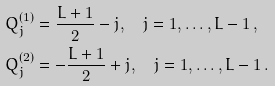<formula> <loc_0><loc_0><loc_500><loc_500>Q _ { j } ^ { ( 1 ) } & = \frac { L + 1 } { 2 } - j , \quad j = 1 , \dots , L - 1 \, , \\ Q _ { j } ^ { ( 2 ) } & = - \frac { L + 1 } { 2 } + j , \quad j = 1 , \dots , L - 1 \, .</formula> 